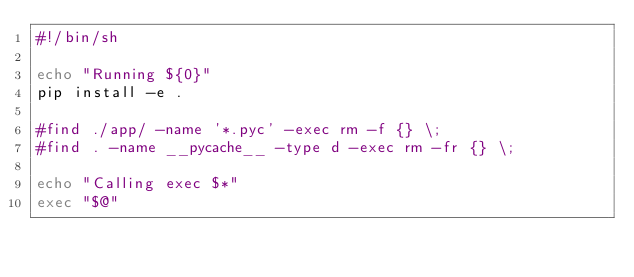<code> <loc_0><loc_0><loc_500><loc_500><_Bash_>#!/bin/sh

echo "Running ${0}"
pip install -e .

#find ./app/ -name '*.pyc' -exec rm -f {} \;
#find . -name __pycache__ -type d -exec rm -fr {} \;

echo "Calling exec $*"
exec "$@"</code> 